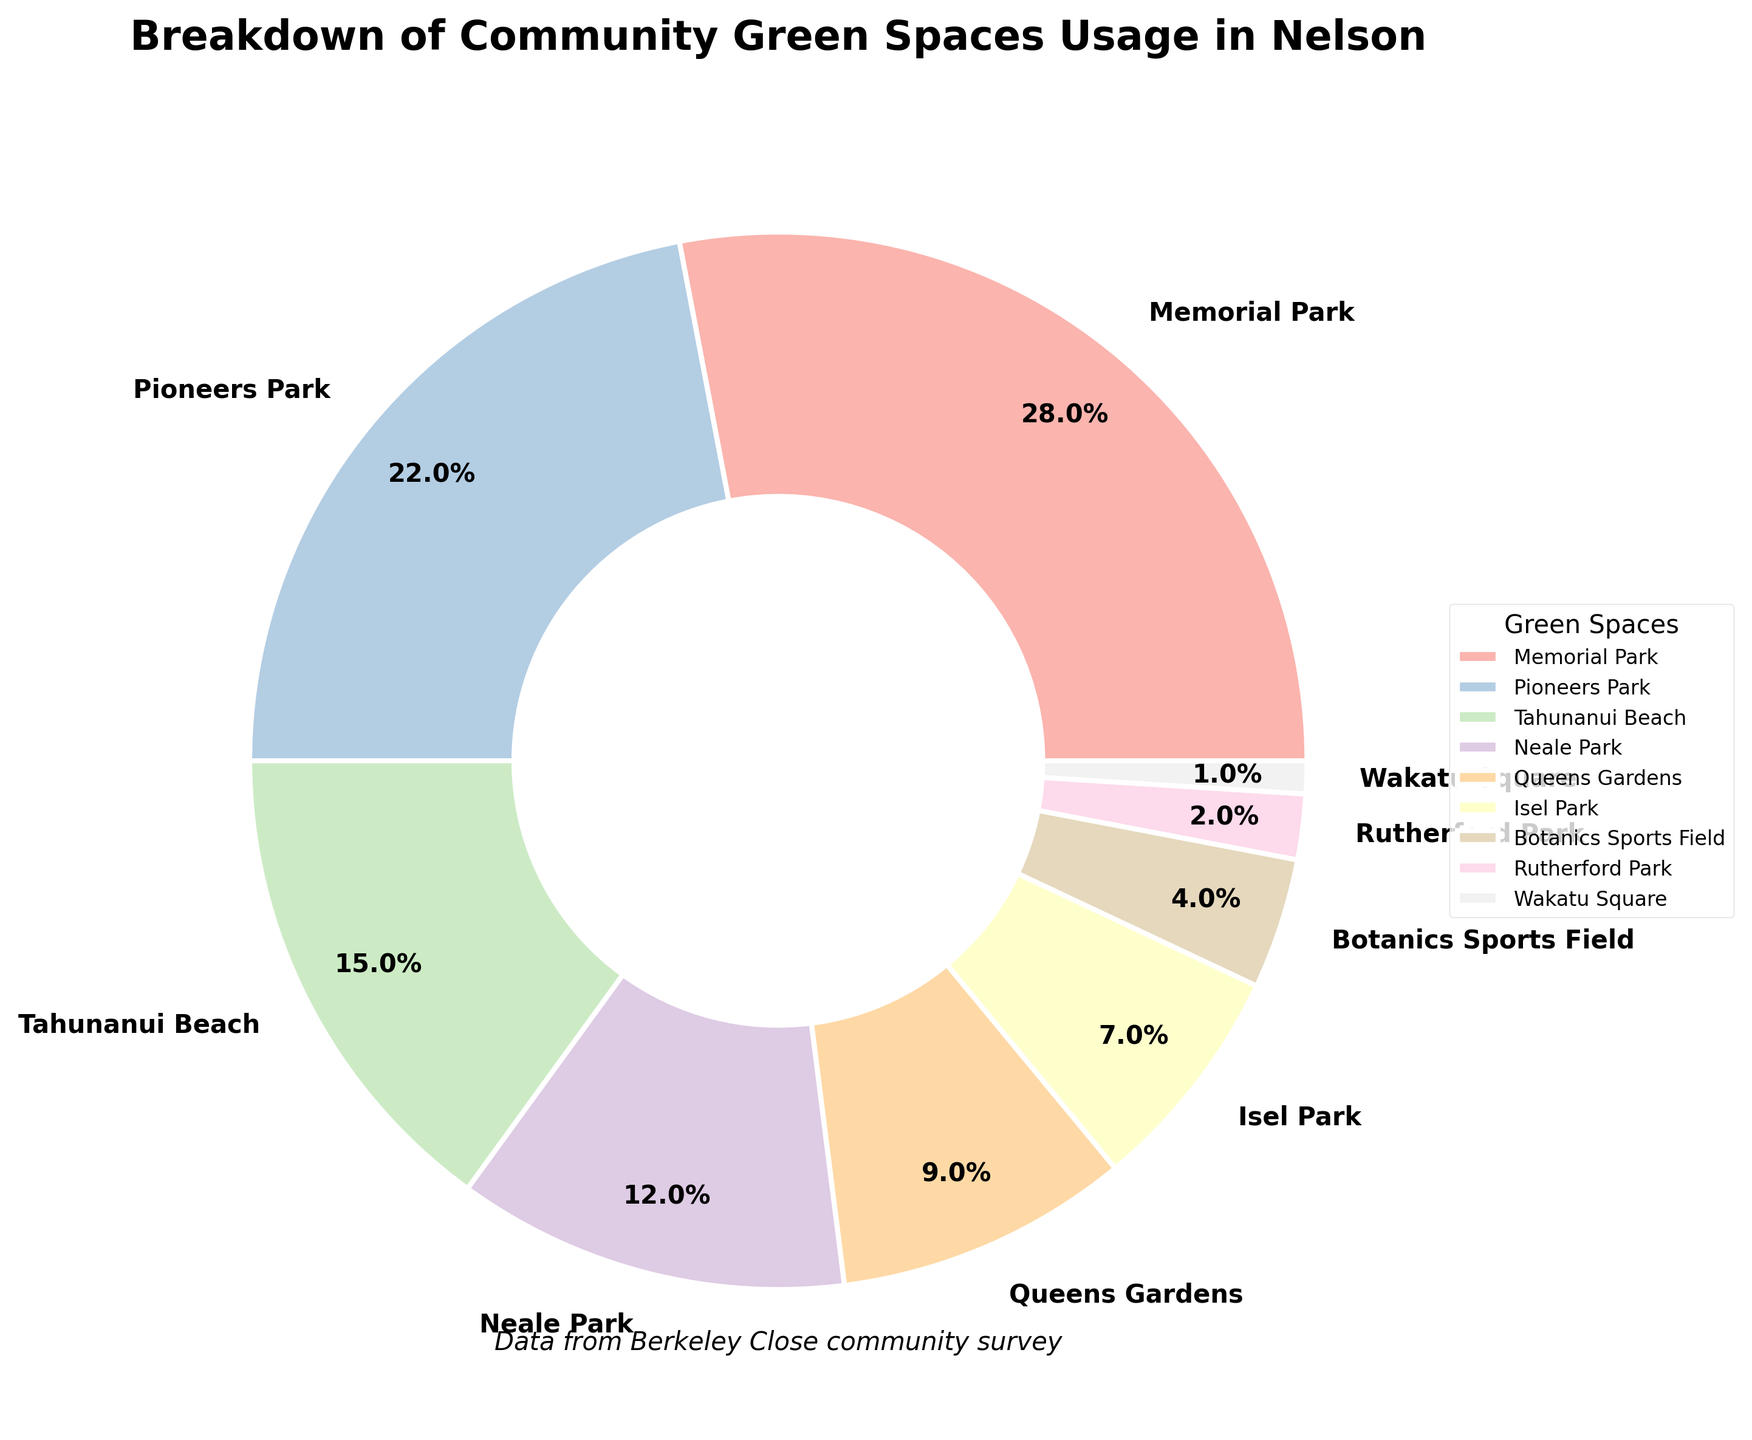What is the most frequently used green space in Nelson? The pie chart shows that Memorial Park has the largest slice, representing 28% of the usage, which is the highest among all listed green spaces.
Answer: Memorial Park Which green space has the least usage percentage? The pie chart indicates that Wakatu Square has the smallest slice, representing just 1% of the usage.
Answer: Wakatu Square What is the total usage percentage of Memorial Park and Pioneers Park combined? According to the pie chart, Memorial Park accounts for 28% and Pioneers Park accounts for 22% of the total usage. Summing these gives 28 + 22 = 50%.
Answer: 50% How does the usage percentage of Neale Park compare to Queens Gardens? The pie chart shows that Neale Park has a usage percentage of 12%, whereas Queens Gardens has a usage percentage of 9%. Therefore, Neale Park has a higher usage percentage than Queens Gardens.
Answer: Neale Park has a higher usage percentage What is the difference in usage percentage between Tahunanui Beach and Isel Park? The pie chart indicates that Tahunanui Beach has a usage percentage of 15%, while Isel Park has 7%. Subtracting these gives 15 - 7 = 8%.
Answer: 8% Which green spaces have a usage percentage below 10%? The pie chart shows Queens Gardens (9%), Isel Park (7%), Botanics Sports Field (4%), Rutherford Park (2%), and Wakatu Square (1%) all have usage percentages below 10%.
Answer: Queens Gardens, Isel Park, Botanics Sports Field, Rutherford Park, Wakatu Square What is the combined usage percentage of the green spaces with less than 5% usage each? The pie chart shows that Botanics Sports Field, Rutherford Park, and Wakatu Square have percentages of 4%, 2%, and 1% respectively. Summing these gives 4 + 2 + 1 = 7%.
Answer: 7% How many green spaces have a usage percentage greater than 20%? The pie chart indicates that Memorial Park (28%) and Pioneers Park (22%) are the only green spaces with usage percentages greater than 20%.
Answer: 2 Which green space has nearly half the usage percentage of Memorial Park? The pie chart indicates Memorial Park has a usage percentage of 28%. Pioneers Park has the closest percentage to half of this at 22%, which is nearly half of 28%.
Answer: Pioneers Park How much more popular is the most used green space compared to the least used one? Memorial Park, the most used green space, has a usage percentage of 28%, while Wakatu Square, the least used, has 1%. The difference is 28 - 1 = 27%.
Answer: 27% 